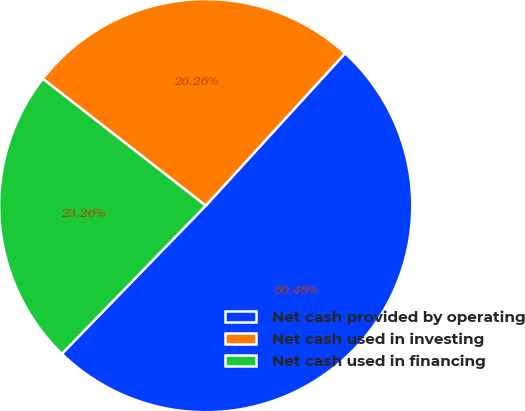Convert chart to OTSL. <chart><loc_0><loc_0><loc_500><loc_500><pie_chart><fcel>Net cash provided by operating<fcel>Net cash used in investing<fcel>Net cash used in financing<nl><fcel>50.48%<fcel>26.26%<fcel>23.26%<nl></chart> 